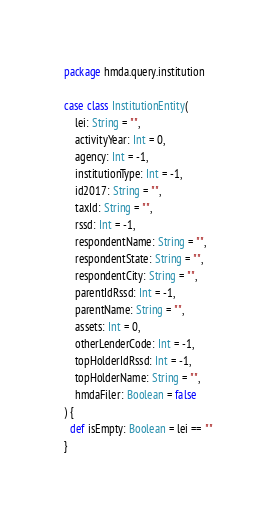<code> <loc_0><loc_0><loc_500><loc_500><_Scala_>package hmda.query.institution

case class InstitutionEntity(
    lei: String = "",
    activityYear: Int = 0,
    agency: Int = -1,
    institutionType: Int = -1,
    id2017: String = "",
    taxId: String = "",
    rssd: Int = -1,
    respondentName: String = "",
    respondentState: String = "",
    respondentCity: String = "",
    parentIdRssd: Int = -1,
    parentName: String = "",
    assets: Int = 0,
    otherLenderCode: Int = -1,
    topHolderIdRssd: Int = -1,
    topHolderName: String = "",
    hmdaFiler: Boolean = false
) {
  def isEmpty: Boolean = lei == ""
}
</code> 